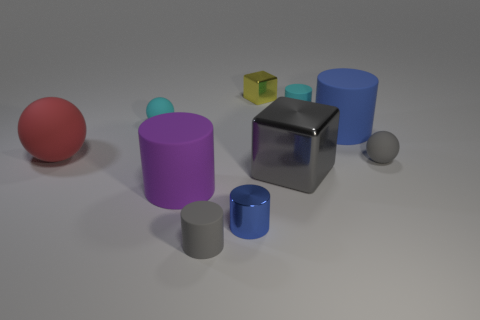Subtract all cyan balls. How many blue cylinders are left? 2 Subtract all big red balls. How many balls are left? 2 Subtract 1 cylinders. How many cylinders are left? 4 Subtract all gray balls. How many balls are left? 2 Subtract all balls. How many objects are left? 7 Subtract 0 blue spheres. How many objects are left? 10 Subtract all cyan blocks. Subtract all cyan cylinders. How many blocks are left? 2 Subtract all cyan rubber cylinders. Subtract all cyan cylinders. How many objects are left? 8 Add 4 small blue objects. How many small blue objects are left? 5 Add 5 gray shiny objects. How many gray shiny objects exist? 6 